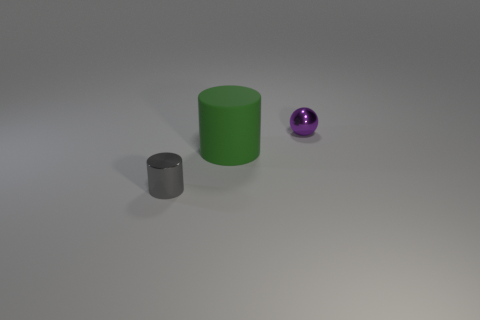Is there anything else that has the same size as the matte cylinder?
Give a very brief answer. No. Are there more large green objects that are to the left of the small shiny cylinder than tiny gray shiny cylinders that are behind the tiny purple object?
Your answer should be very brief. No. What number of objects have the same material as the tiny cylinder?
Your response must be concise. 1. There is a tiny thing that is in front of the tiny purple shiny thing; is it the same shape as the green object in front of the tiny purple object?
Give a very brief answer. Yes. There is a tiny thing that is to the right of the tiny gray shiny object; what is its color?
Your response must be concise. Purple. Is there a gray shiny thing that has the same shape as the big rubber object?
Offer a terse response. Yes. What is the green thing made of?
Give a very brief answer. Rubber. There is a object that is both in front of the small purple metallic thing and behind the metallic cylinder; what is its size?
Your answer should be very brief. Large. How many small gray metallic cylinders are there?
Offer a very short reply. 1. Is the number of small red cubes less than the number of tiny spheres?
Ensure brevity in your answer.  Yes. 